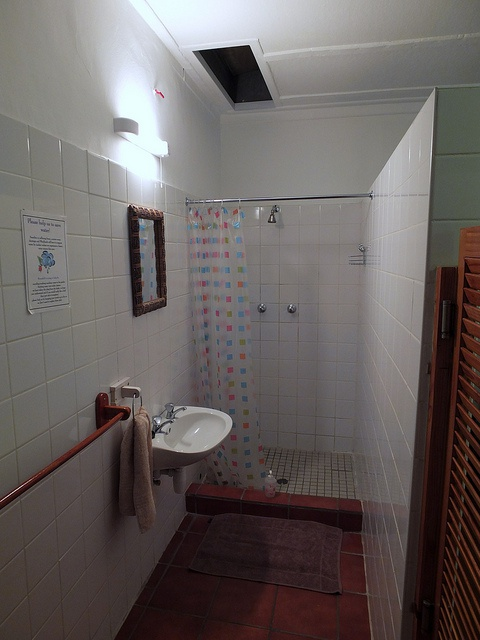Describe the objects in this image and their specific colors. I can see sink in gray, darkgray, and black tones and bottle in gray, maroon, black, and brown tones in this image. 